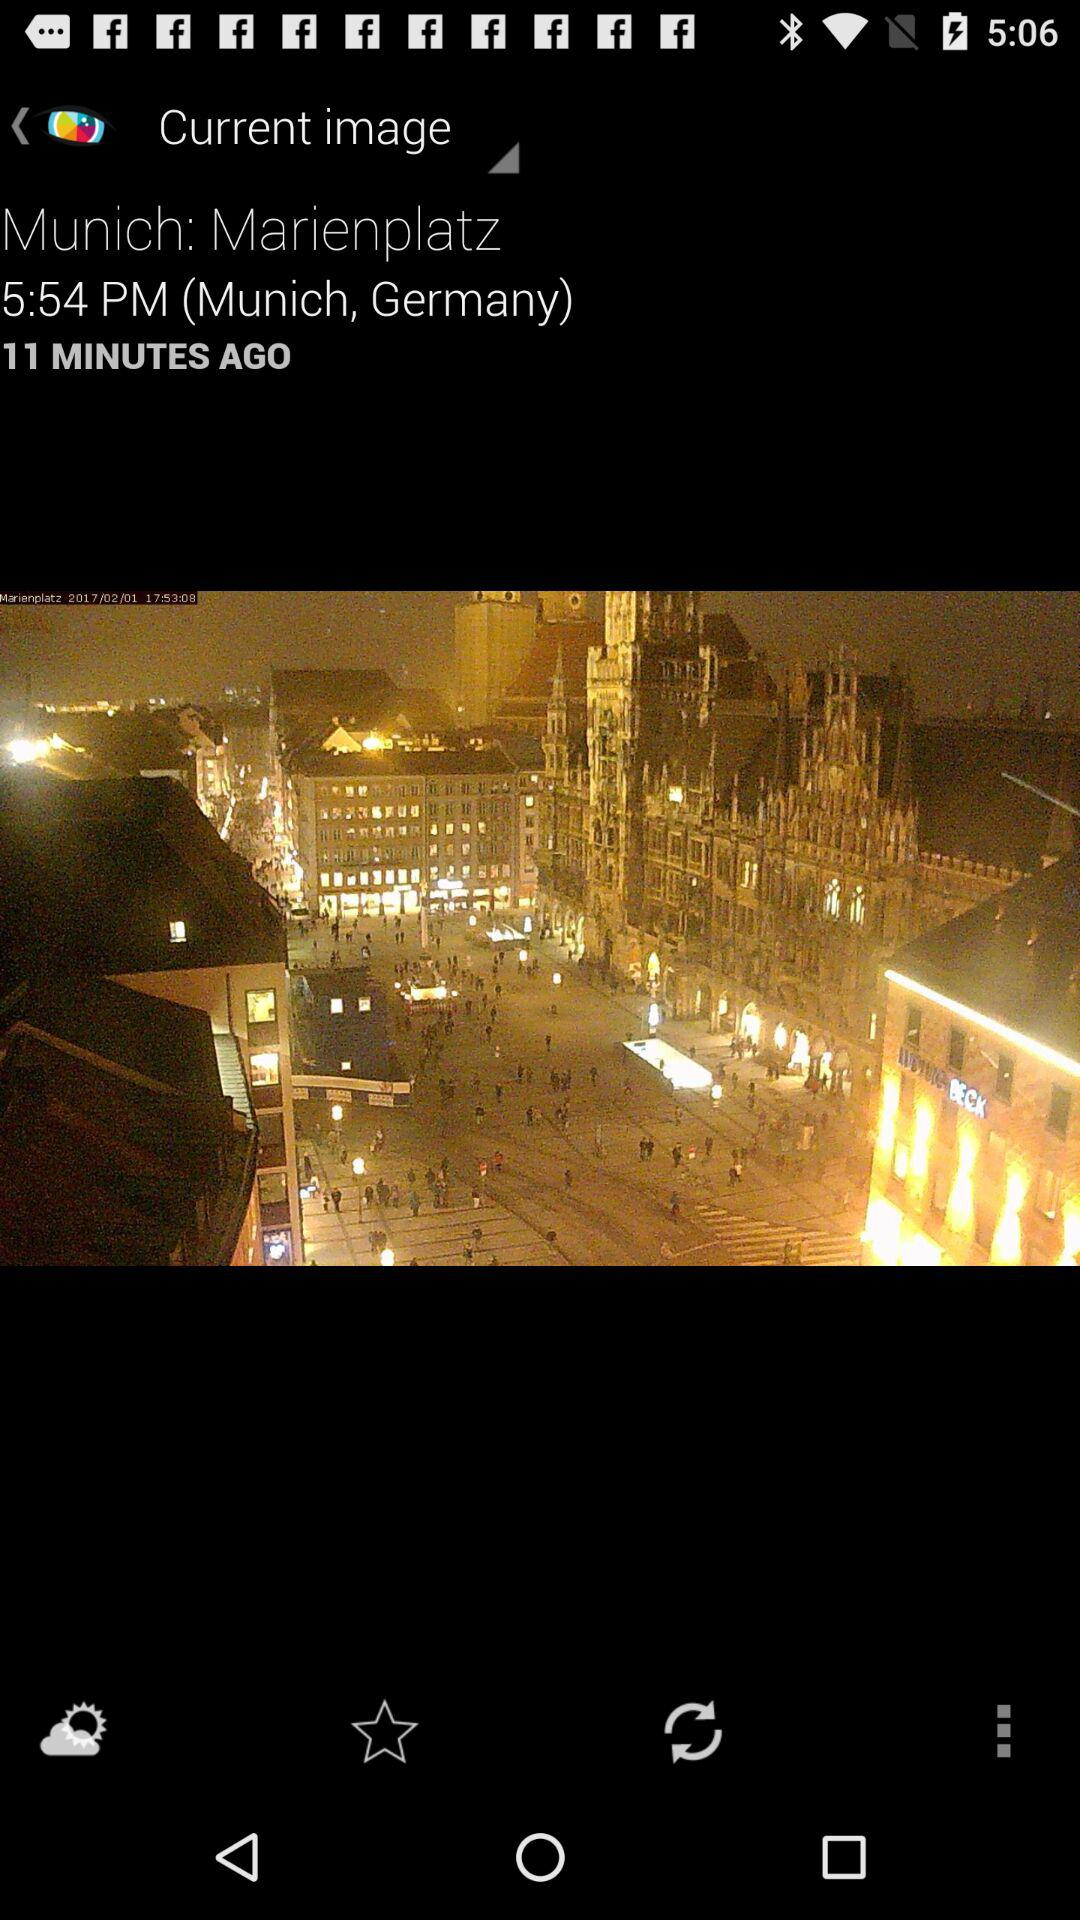What is the location? The location is Marienplatz, Munich, Germany. 